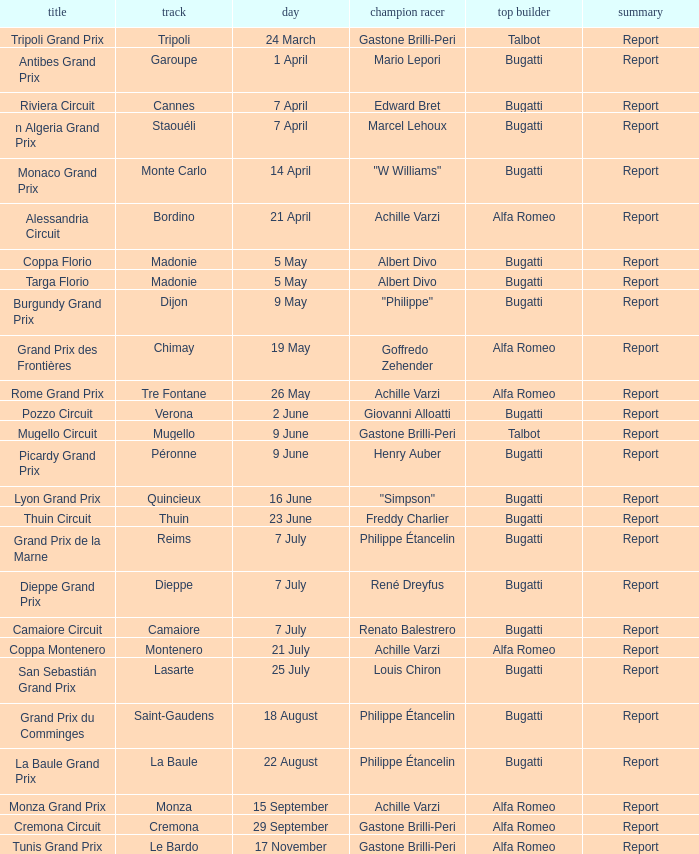What Circuit has a Date of 25 july? Lasarte. 